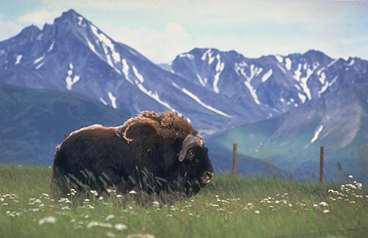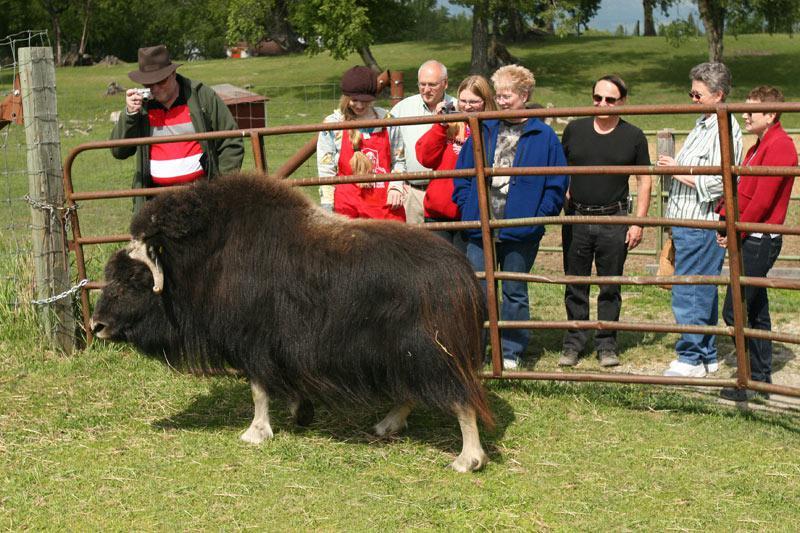The first image is the image on the left, the second image is the image on the right. Analyze the images presented: Is the assertion "An image shows at least one shaggy buffalo standing in a field in front of blue mountains, with fence posts on the right behind the animal." valid? Answer yes or no. Yes. The first image is the image on the left, the second image is the image on the right. For the images displayed, is the sentence "A single bull is walking past a metal fence in the image on the right." factually correct? Answer yes or no. Yes. 